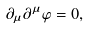Convert formula to latex. <formula><loc_0><loc_0><loc_500><loc_500>\partial _ { \mu } \partial ^ { \mu } \varphi = 0 ,</formula> 